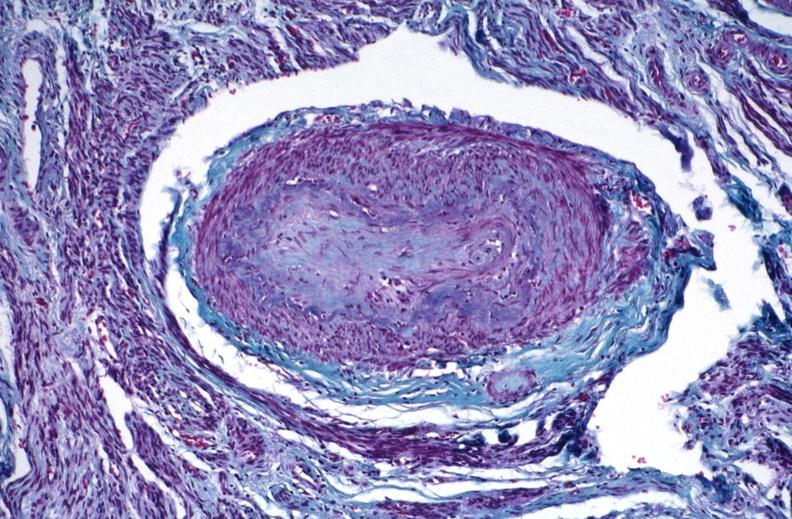does this image show kidney, polyarteritis nodosa?
Answer the question using a single word or phrase. Yes 